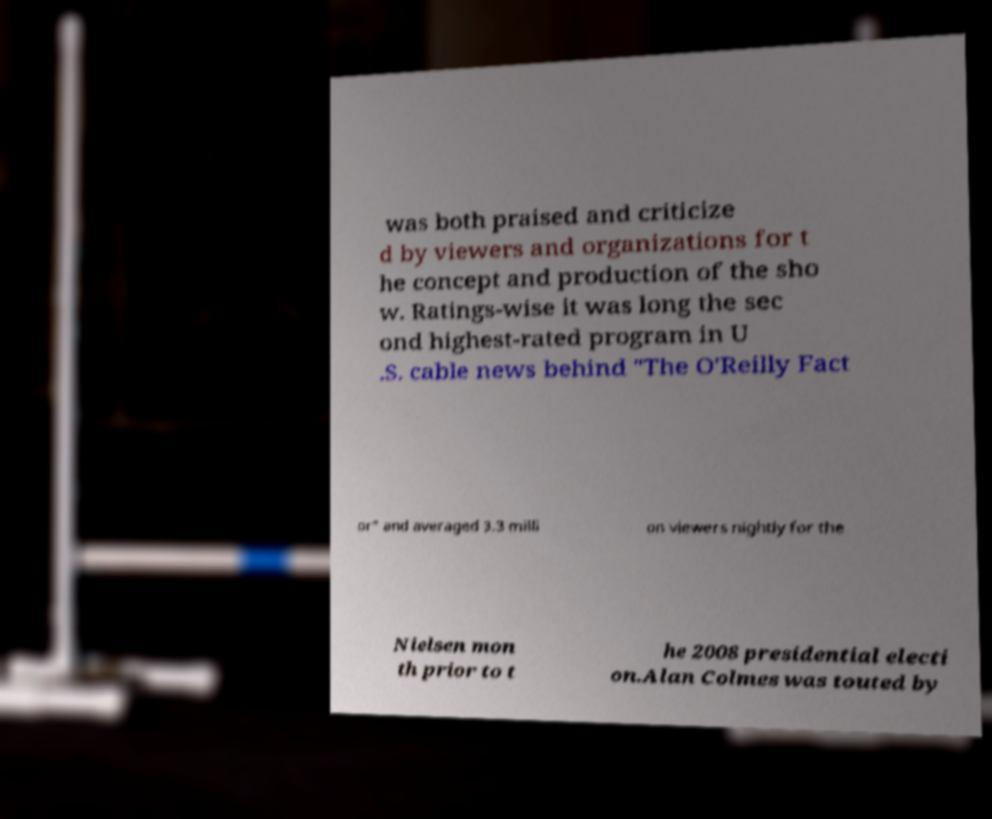Could you assist in decoding the text presented in this image and type it out clearly? was both praised and criticize d by viewers and organizations for t he concept and production of the sho w. Ratings-wise it was long the sec ond highest-rated program in U .S. cable news behind "The O'Reilly Fact or" and averaged 3.3 milli on viewers nightly for the Nielsen mon th prior to t he 2008 presidential electi on.Alan Colmes was touted by 